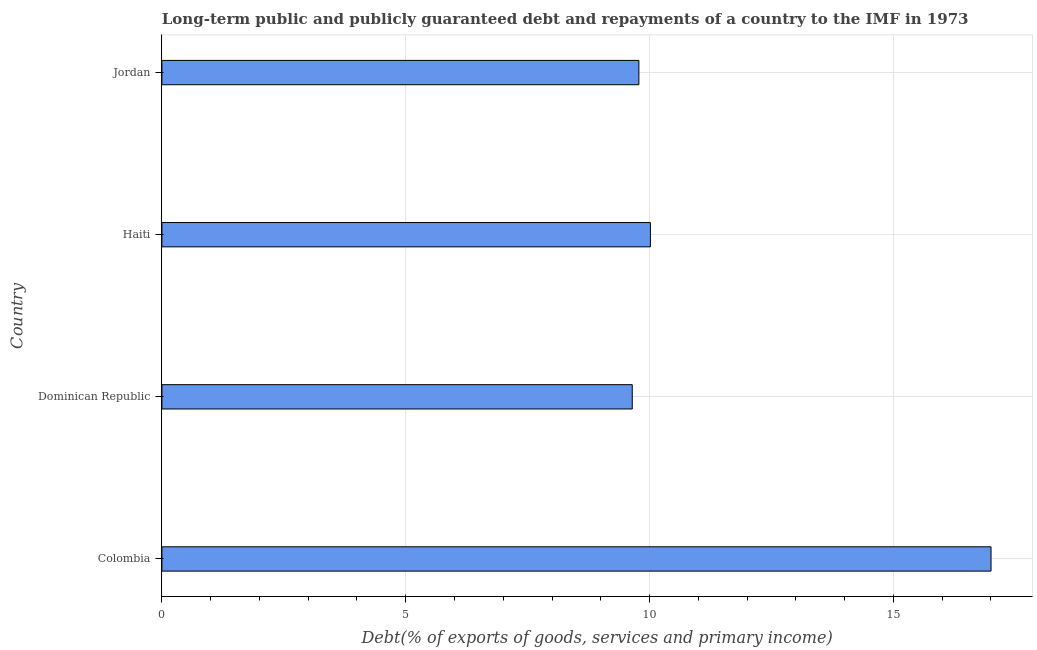What is the title of the graph?
Give a very brief answer. Long-term public and publicly guaranteed debt and repayments of a country to the IMF in 1973. What is the label or title of the X-axis?
Your response must be concise. Debt(% of exports of goods, services and primary income). What is the debt service in Haiti?
Your answer should be compact. 10.02. Across all countries, what is the maximum debt service?
Provide a short and direct response. 17. Across all countries, what is the minimum debt service?
Offer a terse response. 9.64. In which country was the debt service minimum?
Make the answer very short. Dominican Republic. What is the sum of the debt service?
Your answer should be very brief. 46.44. What is the difference between the debt service in Colombia and Jordan?
Your answer should be compact. 7.22. What is the average debt service per country?
Make the answer very short. 11.61. What is the median debt service?
Provide a succinct answer. 9.9. In how many countries, is the debt service greater than 3 %?
Offer a very short reply. 4. What is the ratio of the debt service in Dominican Republic to that in Jordan?
Provide a succinct answer. 0.99. Is the debt service in Colombia less than that in Haiti?
Your answer should be very brief. No. What is the difference between the highest and the second highest debt service?
Your answer should be compact. 6.99. What is the difference between the highest and the lowest debt service?
Ensure brevity in your answer.  7.36. In how many countries, is the debt service greater than the average debt service taken over all countries?
Give a very brief answer. 1. How many bars are there?
Give a very brief answer. 4. Are the values on the major ticks of X-axis written in scientific E-notation?
Give a very brief answer. No. What is the Debt(% of exports of goods, services and primary income) in Colombia?
Make the answer very short. 17. What is the Debt(% of exports of goods, services and primary income) of Dominican Republic?
Your response must be concise. 9.64. What is the Debt(% of exports of goods, services and primary income) in Haiti?
Your response must be concise. 10.02. What is the Debt(% of exports of goods, services and primary income) of Jordan?
Keep it short and to the point. 9.78. What is the difference between the Debt(% of exports of goods, services and primary income) in Colombia and Dominican Republic?
Provide a short and direct response. 7.36. What is the difference between the Debt(% of exports of goods, services and primary income) in Colombia and Haiti?
Give a very brief answer. 6.98. What is the difference between the Debt(% of exports of goods, services and primary income) in Colombia and Jordan?
Your response must be concise. 7.22. What is the difference between the Debt(% of exports of goods, services and primary income) in Dominican Republic and Haiti?
Offer a terse response. -0.37. What is the difference between the Debt(% of exports of goods, services and primary income) in Dominican Republic and Jordan?
Your answer should be compact. -0.14. What is the difference between the Debt(% of exports of goods, services and primary income) in Haiti and Jordan?
Provide a succinct answer. 0.24. What is the ratio of the Debt(% of exports of goods, services and primary income) in Colombia to that in Dominican Republic?
Offer a terse response. 1.76. What is the ratio of the Debt(% of exports of goods, services and primary income) in Colombia to that in Haiti?
Offer a very short reply. 1.7. What is the ratio of the Debt(% of exports of goods, services and primary income) in Colombia to that in Jordan?
Give a very brief answer. 1.74. What is the ratio of the Debt(% of exports of goods, services and primary income) in Dominican Republic to that in Haiti?
Make the answer very short. 0.96. What is the ratio of the Debt(% of exports of goods, services and primary income) in Dominican Republic to that in Jordan?
Give a very brief answer. 0.99. 